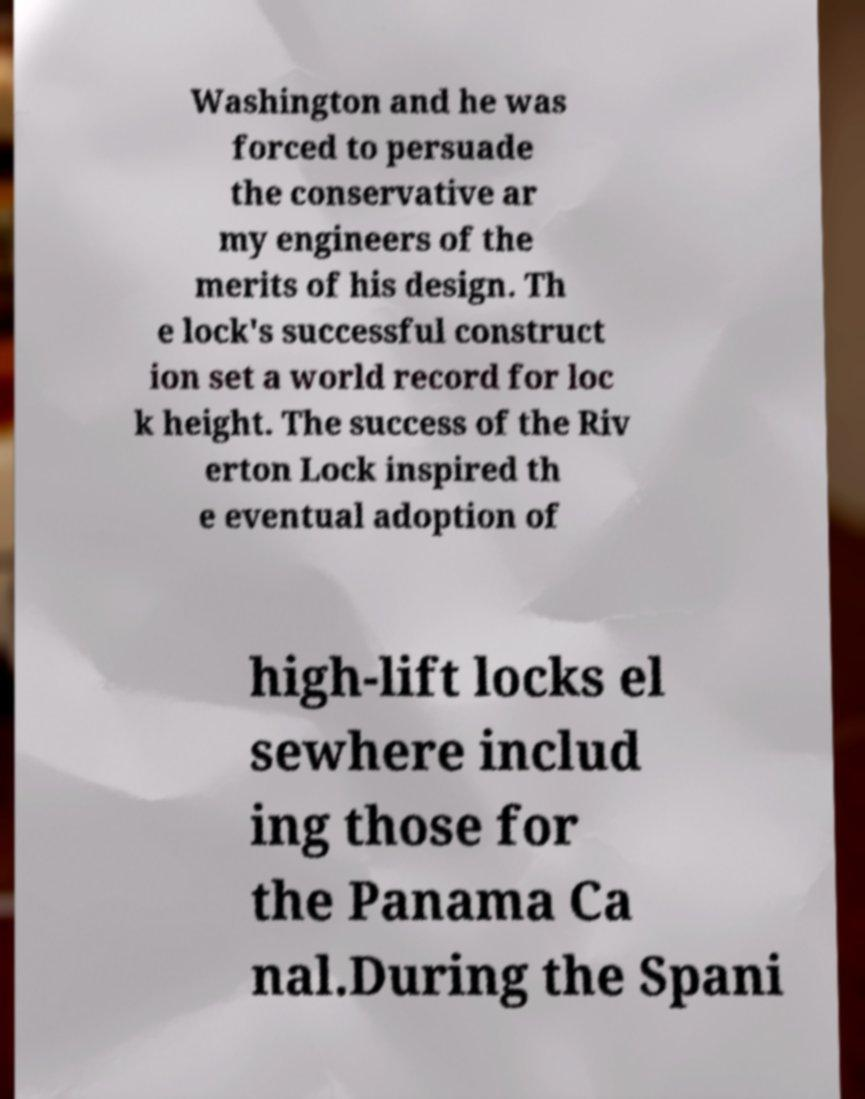Can you accurately transcribe the text from the provided image for me? Washington and he was forced to persuade the conservative ar my engineers of the merits of his design. Th e lock's successful construct ion set a world record for loc k height. The success of the Riv erton Lock inspired th e eventual adoption of high-lift locks el sewhere includ ing those for the Panama Ca nal.During the Spani 